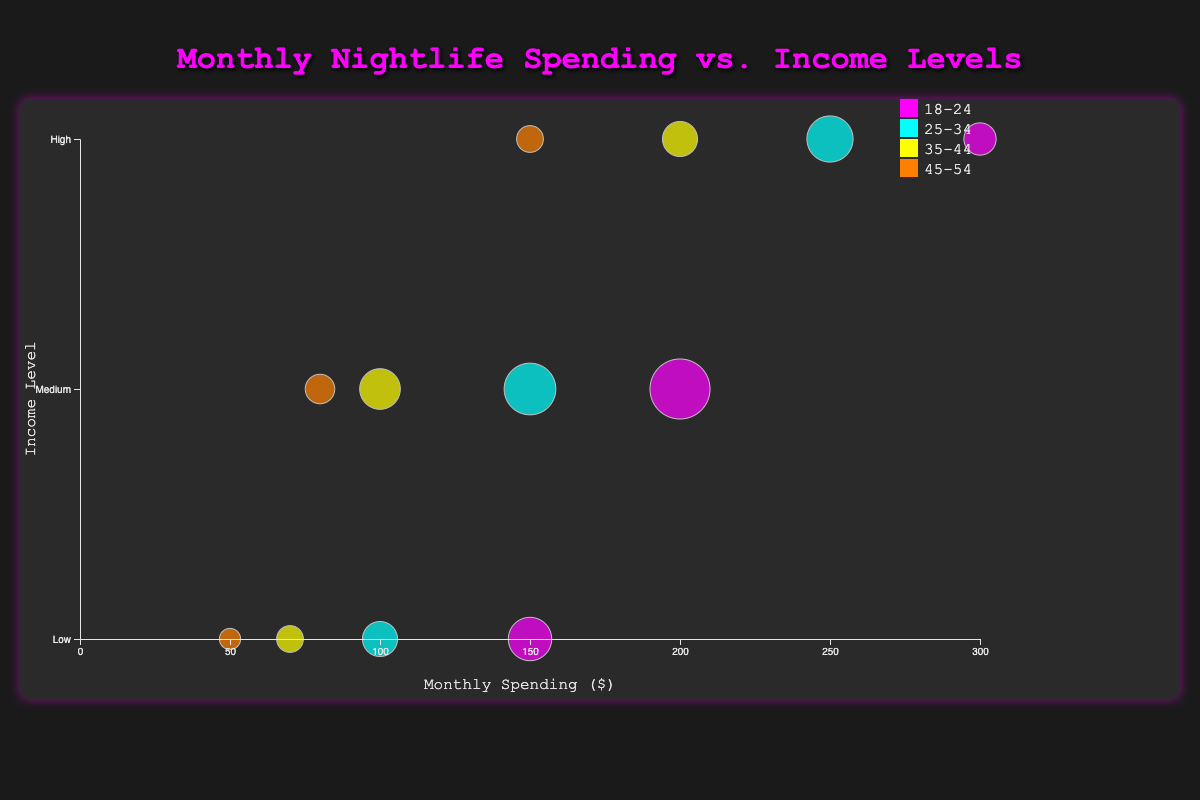What's the title of the chart? The title is located at the top center of the chart. It reads "Monthly Nightlife Spending vs. Income Levels".
Answer: Monthly Nightlife Spending vs. Income Levels What are the axis labels in the chart? The x-axis label at the bottom of the chart is "Monthly Spending ($)", and the y-axis label on the left side of the chart is "Income Level".
Answer: Monthly Spending ($), Income Level Which age group has the highest spending for high-income levels? High-income levels are represented on the y-axis with the top-most point where the age group "18-24" is associated with a circle representing $300 in spending.
Answer: 18-24 How many bubbles representing people in the medium-income level aged 25-34? Locate the medium-income level on the y-axis, then look for bubbles along this axis. For the age group "25-34", there's only one bubble with $150 in spending and a corresponding radius.
Answer: 1 bubble What's the difference in spending between high-income levels for age groups 18-24 and 25-34? Find the monthly spending for high-income levels of both age groups, $300 for 18-24 and $250 for 25-34, then calculate the difference: $300 - $250.
Answer: $50 Compare the spending for low-income levels for age groups 35-44 and 45-54. Which one spends more? Find the monthly spending for low-income levels of both age groups, $70 for 35-44 and $50 for 45-54; 35-44 spends more.
Answer: 35-44 spends more What is the total number of people in the chart for high-income levels across all age groups? Sum up the number of people for high-income levels across the age groups: 80 (18-24) + 130 (25-34) + 90 (35-44) + 60 (45-54) = 360.
Answer: 360 Which income level has the largest total number of people across all age groups? Sum the number of people for each income level across all age groups. The totals are 310 (Low), 510 (Medium), 360 (High). Medium has the highest total.
Answer: Medium What is the average monthly spending for the age group 18-24? Sum the monthly spending for 18-24: 150 (Low) + 200 (Medium) + 300 (High) = 650. There are 3 levels, so average is 650 / 3 = 216.67.
Answer: 216.67 